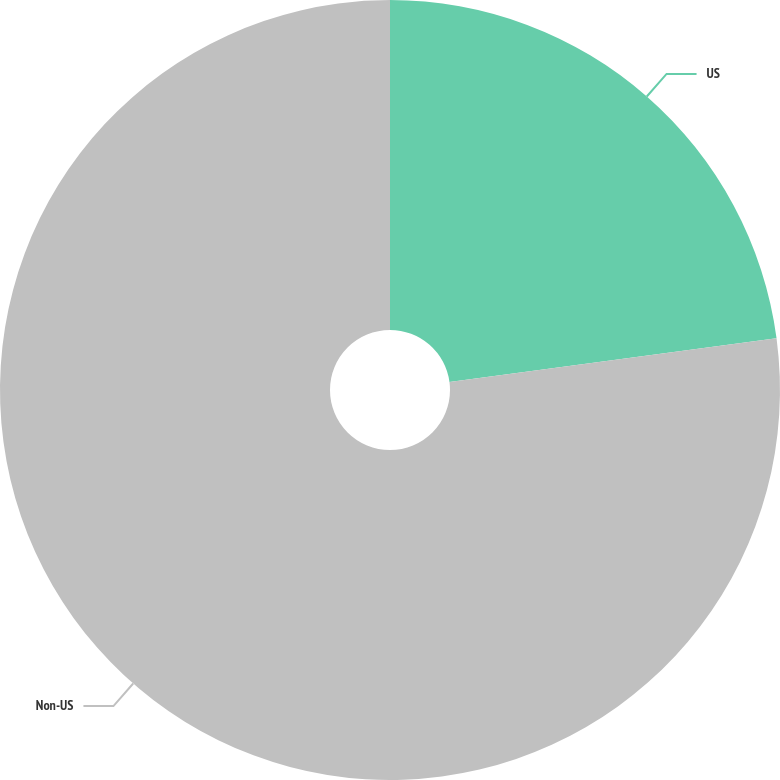Convert chart. <chart><loc_0><loc_0><loc_500><loc_500><pie_chart><fcel>US<fcel>Non-US<nl><fcel>22.88%<fcel>77.12%<nl></chart> 